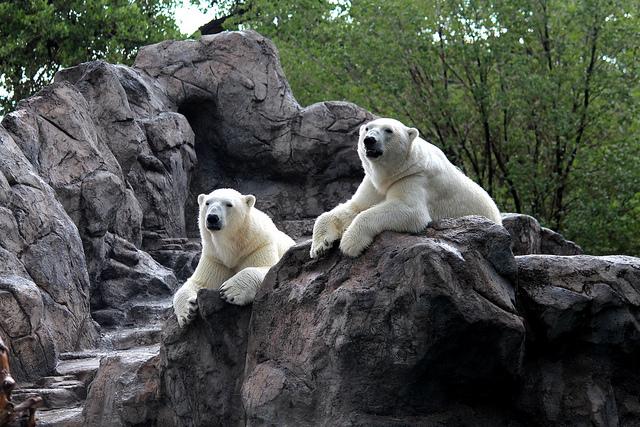What color are the bears?
Keep it brief. White. How many bears are there?
Give a very brief answer. 2. What type of bears are these?
Give a very brief answer. Polar. 